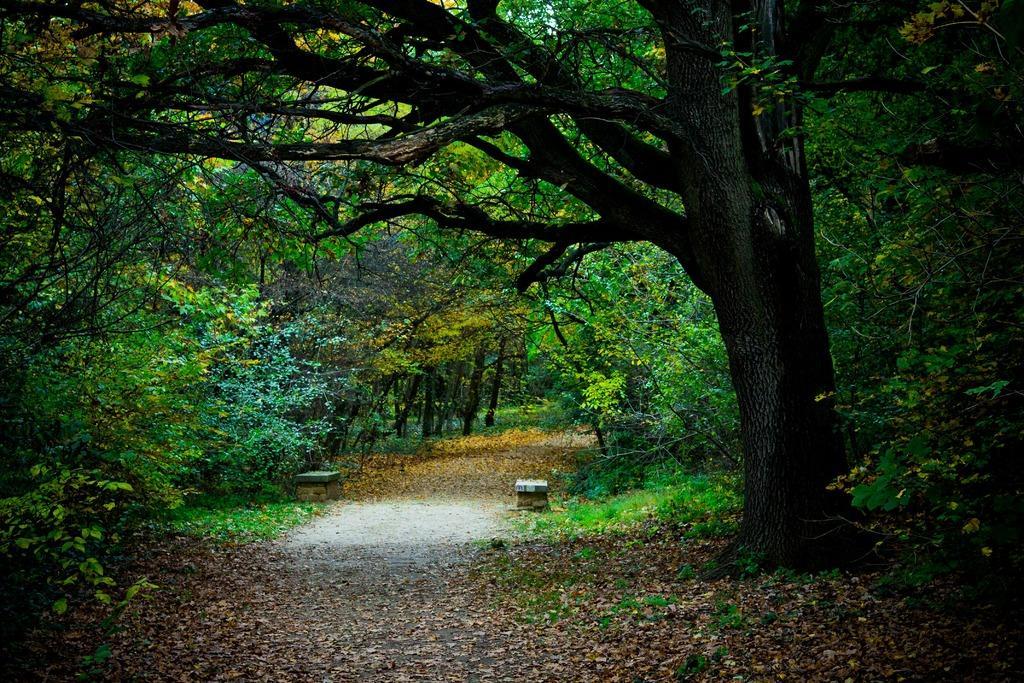Please provide a concise description of this image. In the image in the center, we can see trees, benches, plants, grass and dry leaves. 